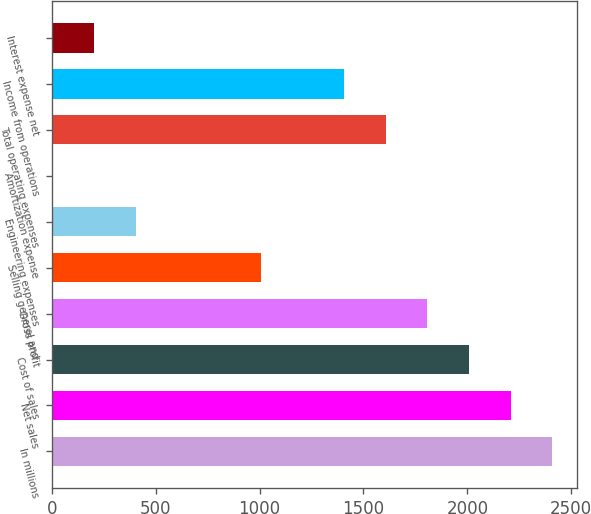<chart> <loc_0><loc_0><loc_500><loc_500><bar_chart><fcel>In millions<fcel>Net sales<fcel>Cost of sales<fcel>Gross profit<fcel>Selling general and<fcel>Engineering expenses<fcel>Amortization expense<fcel>Total operating expenses<fcel>Income from operations<fcel>Interest expense net<nl><fcel>2408.58<fcel>2208.29<fcel>2008<fcel>1807.71<fcel>1006.55<fcel>405.68<fcel>5.1<fcel>1607.42<fcel>1407.13<fcel>205.39<nl></chart> 